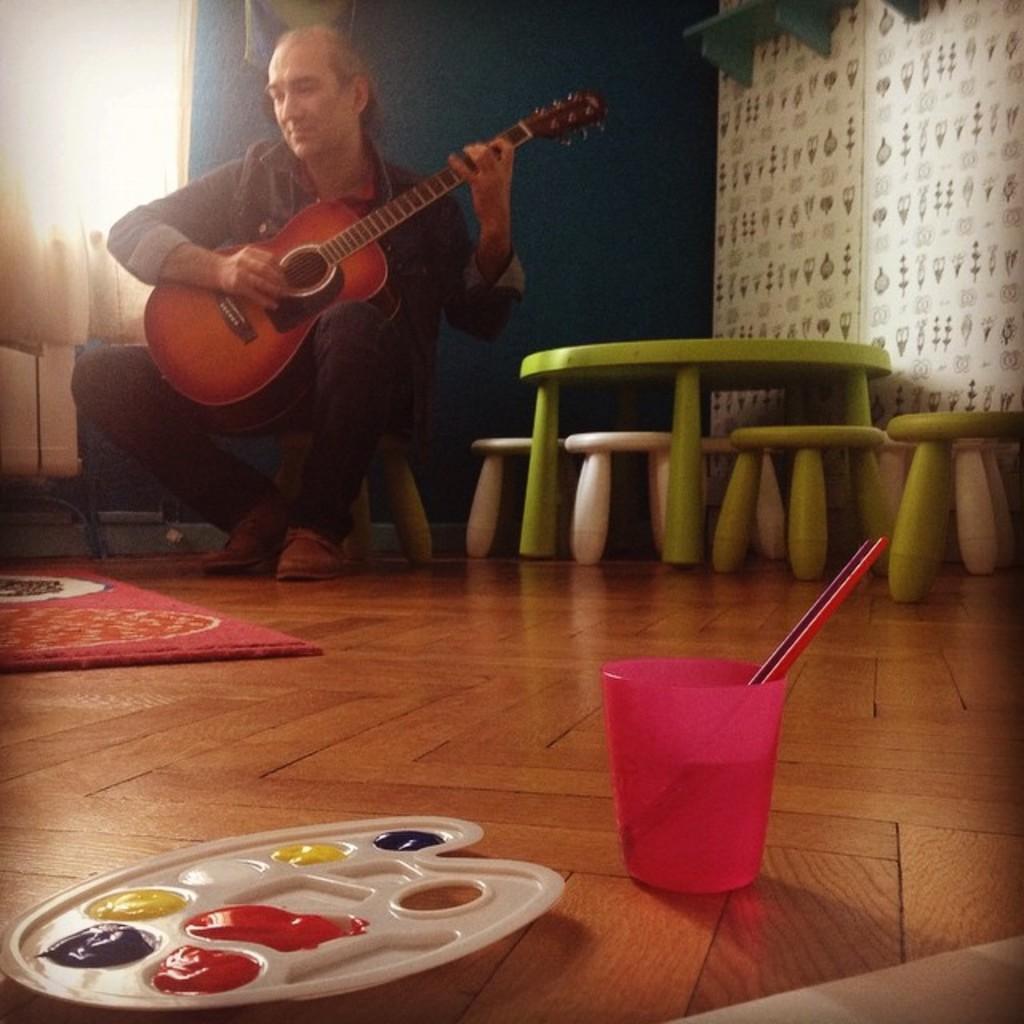In one or two sentences, can you explain what this image depicts? Here we can see a man sitting on a stool playing a guitar and beside him we can see table and stools present and in front of him we can see colors and a glass present 